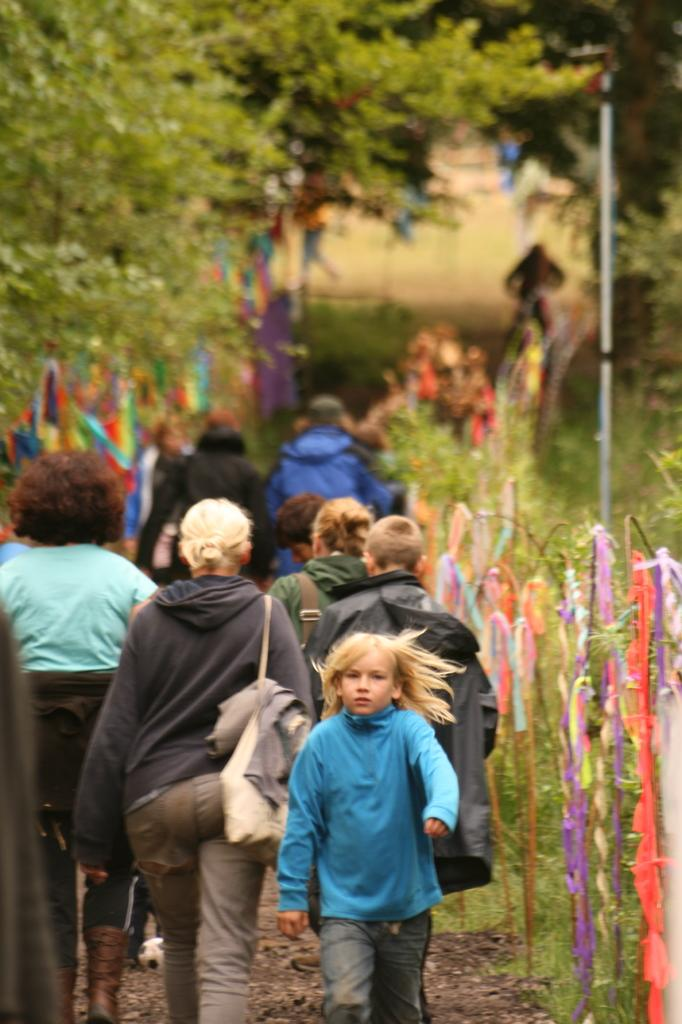Where was the image taken? The image was clicked outside. What can be seen in the background of the image? There are trees at the top of the image. What are the people in the image doing? There are multiple persons walking in the middle of the image. What type of arch can be seen in the image? There is no arch present in the image. What does the image smell like? The image does not have a smell, as it is a visual representation. 